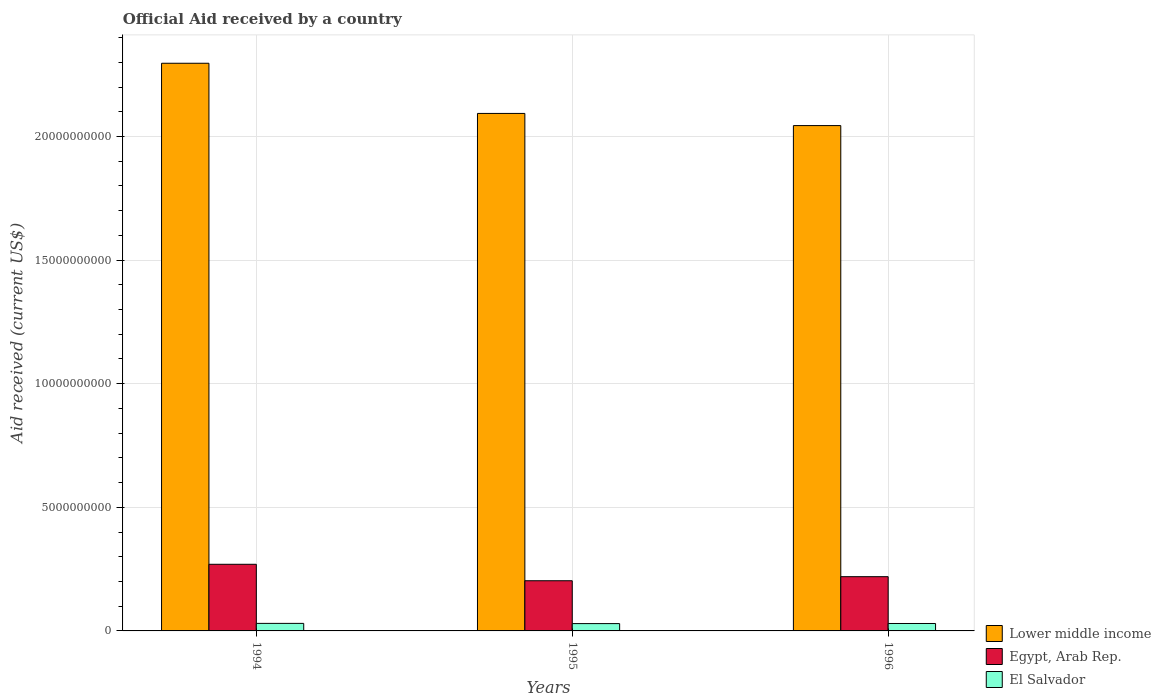How many different coloured bars are there?
Provide a short and direct response. 3. What is the label of the 2nd group of bars from the left?
Keep it short and to the point. 1995. What is the net official aid received in Lower middle income in 1994?
Ensure brevity in your answer.  2.30e+1. Across all years, what is the maximum net official aid received in El Salvador?
Ensure brevity in your answer.  3.05e+08. Across all years, what is the minimum net official aid received in Egypt, Arab Rep.?
Keep it short and to the point. 2.03e+09. In which year was the net official aid received in Egypt, Arab Rep. maximum?
Ensure brevity in your answer.  1994. In which year was the net official aid received in Lower middle income minimum?
Offer a terse response. 1996. What is the total net official aid received in Lower middle income in the graph?
Provide a short and direct response. 6.43e+1. What is the difference between the net official aid received in Lower middle income in 1994 and that in 1995?
Offer a terse response. 2.03e+09. What is the difference between the net official aid received in El Salvador in 1996 and the net official aid received in Lower middle income in 1995?
Offer a terse response. -2.06e+1. What is the average net official aid received in Egypt, Arab Rep. per year?
Provide a succinct answer. 2.31e+09. In the year 1995, what is the difference between the net official aid received in Lower middle income and net official aid received in El Salvador?
Provide a succinct answer. 2.06e+1. In how many years, is the net official aid received in Egypt, Arab Rep. greater than 6000000000 US$?
Offer a very short reply. 0. What is the ratio of the net official aid received in Egypt, Arab Rep. in 1995 to that in 1996?
Provide a succinct answer. 0.93. Is the net official aid received in Egypt, Arab Rep. in 1994 less than that in 1996?
Keep it short and to the point. No. What is the difference between the highest and the second highest net official aid received in El Salvador?
Make the answer very short. 4.35e+06. What is the difference between the highest and the lowest net official aid received in El Salvador?
Make the answer very short. 9.16e+06. In how many years, is the net official aid received in El Salvador greater than the average net official aid received in El Salvador taken over all years?
Offer a very short reply. 2. What does the 1st bar from the left in 1994 represents?
Your answer should be compact. Lower middle income. What does the 3rd bar from the right in 1995 represents?
Provide a short and direct response. Lower middle income. How many bars are there?
Ensure brevity in your answer.  9. Are all the bars in the graph horizontal?
Keep it short and to the point. No. What is the difference between two consecutive major ticks on the Y-axis?
Your answer should be compact. 5.00e+09. Are the values on the major ticks of Y-axis written in scientific E-notation?
Ensure brevity in your answer.  No. Does the graph contain any zero values?
Your answer should be very brief. No. Where does the legend appear in the graph?
Your answer should be very brief. Bottom right. How are the legend labels stacked?
Provide a short and direct response. Vertical. What is the title of the graph?
Make the answer very short. Official Aid received by a country. What is the label or title of the Y-axis?
Your answer should be compact. Aid received (current US$). What is the Aid received (current US$) of Lower middle income in 1994?
Make the answer very short. 2.30e+1. What is the Aid received (current US$) in Egypt, Arab Rep. in 1994?
Give a very brief answer. 2.69e+09. What is the Aid received (current US$) in El Salvador in 1994?
Ensure brevity in your answer.  3.05e+08. What is the Aid received (current US$) of Lower middle income in 1995?
Provide a short and direct response. 2.09e+1. What is the Aid received (current US$) in Egypt, Arab Rep. in 1995?
Offer a terse response. 2.03e+09. What is the Aid received (current US$) of El Salvador in 1995?
Offer a terse response. 2.96e+08. What is the Aid received (current US$) in Lower middle income in 1996?
Ensure brevity in your answer.  2.04e+1. What is the Aid received (current US$) in Egypt, Arab Rep. in 1996?
Ensure brevity in your answer.  2.19e+09. What is the Aid received (current US$) in El Salvador in 1996?
Keep it short and to the point. 3.01e+08. Across all years, what is the maximum Aid received (current US$) of Lower middle income?
Ensure brevity in your answer.  2.30e+1. Across all years, what is the maximum Aid received (current US$) of Egypt, Arab Rep.?
Offer a very short reply. 2.69e+09. Across all years, what is the maximum Aid received (current US$) in El Salvador?
Keep it short and to the point. 3.05e+08. Across all years, what is the minimum Aid received (current US$) in Lower middle income?
Make the answer very short. 2.04e+1. Across all years, what is the minimum Aid received (current US$) in Egypt, Arab Rep.?
Ensure brevity in your answer.  2.03e+09. Across all years, what is the minimum Aid received (current US$) of El Salvador?
Offer a very short reply. 2.96e+08. What is the total Aid received (current US$) in Lower middle income in the graph?
Make the answer very short. 6.43e+1. What is the total Aid received (current US$) of Egypt, Arab Rep. in the graph?
Make the answer very short. 6.92e+09. What is the total Aid received (current US$) of El Salvador in the graph?
Provide a short and direct response. 9.02e+08. What is the difference between the Aid received (current US$) in Lower middle income in 1994 and that in 1995?
Give a very brief answer. 2.03e+09. What is the difference between the Aid received (current US$) in Egypt, Arab Rep. in 1994 and that in 1995?
Offer a terse response. 6.65e+08. What is the difference between the Aid received (current US$) of El Salvador in 1994 and that in 1995?
Ensure brevity in your answer.  9.16e+06. What is the difference between the Aid received (current US$) in Lower middle income in 1994 and that in 1996?
Provide a succinct answer. 2.52e+09. What is the difference between the Aid received (current US$) in Egypt, Arab Rep. in 1994 and that in 1996?
Your answer should be compact. 5.01e+08. What is the difference between the Aid received (current US$) in El Salvador in 1994 and that in 1996?
Keep it short and to the point. 4.35e+06. What is the difference between the Aid received (current US$) of Lower middle income in 1995 and that in 1996?
Your answer should be very brief. 4.92e+08. What is the difference between the Aid received (current US$) in Egypt, Arab Rep. in 1995 and that in 1996?
Give a very brief answer. -1.64e+08. What is the difference between the Aid received (current US$) of El Salvador in 1995 and that in 1996?
Keep it short and to the point. -4.81e+06. What is the difference between the Aid received (current US$) of Lower middle income in 1994 and the Aid received (current US$) of Egypt, Arab Rep. in 1995?
Your answer should be compact. 2.09e+1. What is the difference between the Aid received (current US$) of Lower middle income in 1994 and the Aid received (current US$) of El Salvador in 1995?
Give a very brief answer. 2.27e+1. What is the difference between the Aid received (current US$) in Egypt, Arab Rep. in 1994 and the Aid received (current US$) in El Salvador in 1995?
Ensure brevity in your answer.  2.40e+09. What is the difference between the Aid received (current US$) of Lower middle income in 1994 and the Aid received (current US$) of Egypt, Arab Rep. in 1996?
Give a very brief answer. 2.08e+1. What is the difference between the Aid received (current US$) of Lower middle income in 1994 and the Aid received (current US$) of El Salvador in 1996?
Ensure brevity in your answer.  2.27e+1. What is the difference between the Aid received (current US$) in Egypt, Arab Rep. in 1994 and the Aid received (current US$) in El Salvador in 1996?
Give a very brief answer. 2.39e+09. What is the difference between the Aid received (current US$) of Lower middle income in 1995 and the Aid received (current US$) of Egypt, Arab Rep. in 1996?
Offer a very short reply. 1.87e+1. What is the difference between the Aid received (current US$) in Lower middle income in 1995 and the Aid received (current US$) in El Salvador in 1996?
Provide a short and direct response. 2.06e+1. What is the difference between the Aid received (current US$) of Egypt, Arab Rep. in 1995 and the Aid received (current US$) of El Salvador in 1996?
Offer a very short reply. 1.73e+09. What is the average Aid received (current US$) of Lower middle income per year?
Offer a very short reply. 2.14e+1. What is the average Aid received (current US$) of Egypt, Arab Rep. per year?
Offer a terse response. 2.31e+09. What is the average Aid received (current US$) in El Salvador per year?
Ensure brevity in your answer.  3.01e+08. In the year 1994, what is the difference between the Aid received (current US$) of Lower middle income and Aid received (current US$) of Egypt, Arab Rep.?
Ensure brevity in your answer.  2.03e+1. In the year 1994, what is the difference between the Aid received (current US$) in Lower middle income and Aid received (current US$) in El Salvador?
Give a very brief answer. 2.27e+1. In the year 1994, what is the difference between the Aid received (current US$) in Egypt, Arab Rep. and Aid received (current US$) in El Salvador?
Make the answer very short. 2.39e+09. In the year 1995, what is the difference between the Aid received (current US$) of Lower middle income and Aid received (current US$) of Egypt, Arab Rep.?
Provide a short and direct response. 1.89e+1. In the year 1995, what is the difference between the Aid received (current US$) of Lower middle income and Aid received (current US$) of El Salvador?
Make the answer very short. 2.06e+1. In the year 1995, what is the difference between the Aid received (current US$) in Egypt, Arab Rep. and Aid received (current US$) in El Salvador?
Your answer should be very brief. 1.73e+09. In the year 1996, what is the difference between the Aid received (current US$) of Lower middle income and Aid received (current US$) of Egypt, Arab Rep.?
Provide a succinct answer. 1.82e+1. In the year 1996, what is the difference between the Aid received (current US$) of Lower middle income and Aid received (current US$) of El Salvador?
Provide a short and direct response. 2.01e+1. In the year 1996, what is the difference between the Aid received (current US$) of Egypt, Arab Rep. and Aid received (current US$) of El Salvador?
Offer a terse response. 1.89e+09. What is the ratio of the Aid received (current US$) of Lower middle income in 1994 to that in 1995?
Your answer should be very brief. 1.1. What is the ratio of the Aid received (current US$) in Egypt, Arab Rep. in 1994 to that in 1995?
Ensure brevity in your answer.  1.33. What is the ratio of the Aid received (current US$) of El Salvador in 1994 to that in 1995?
Ensure brevity in your answer.  1.03. What is the ratio of the Aid received (current US$) of Lower middle income in 1994 to that in 1996?
Ensure brevity in your answer.  1.12. What is the ratio of the Aid received (current US$) of Egypt, Arab Rep. in 1994 to that in 1996?
Offer a terse response. 1.23. What is the ratio of the Aid received (current US$) of El Salvador in 1994 to that in 1996?
Offer a terse response. 1.01. What is the ratio of the Aid received (current US$) of Lower middle income in 1995 to that in 1996?
Offer a terse response. 1.02. What is the ratio of the Aid received (current US$) in Egypt, Arab Rep. in 1995 to that in 1996?
Provide a succinct answer. 0.93. What is the ratio of the Aid received (current US$) in El Salvador in 1995 to that in 1996?
Keep it short and to the point. 0.98. What is the difference between the highest and the second highest Aid received (current US$) of Lower middle income?
Provide a short and direct response. 2.03e+09. What is the difference between the highest and the second highest Aid received (current US$) of Egypt, Arab Rep.?
Provide a short and direct response. 5.01e+08. What is the difference between the highest and the second highest Aid received (current US$) in El Salvador?
Give a very brief answer. 4.35e+06. What is the difference between the highest and the lowest Aid received (current US$) of Lower middle income?
Offer a very short reply. 2.52e+09. What is the difference between the highest and the lowest Aid received (current US$) of Egypt, Arab Rep.?
Provide a short and direct response. 6.65e+08. What is the difference between the highest and the lowest Aid received (current US$) of El Salvador?
Offer a very short reply. 9.16e+06. 